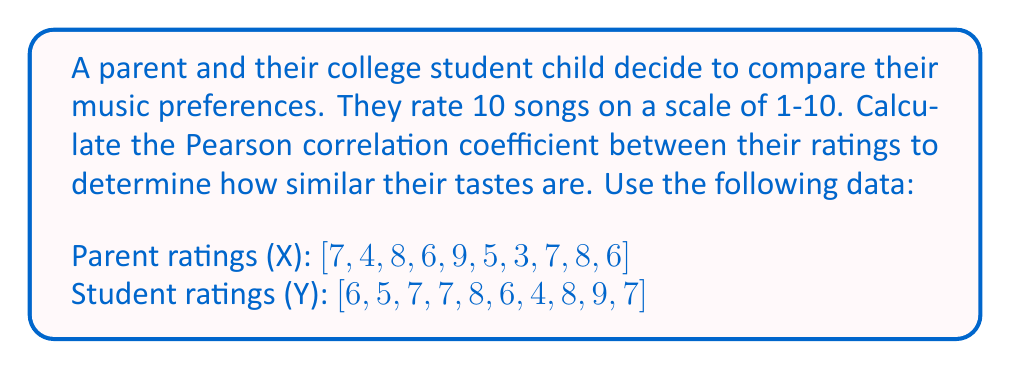Can you answer this question? To calculate the Pearson correlation coefficient, we'll use the formula:

$$ r = \frac{\sum_{i=1}^{n} (x_i - \bar{x})(y_i - \bar{y})}{\sqrt{\sum_{i=1}^{n} (x_i - \bar{x})^2 \sum_{i=1}^{n} (y_i - \bar{y})^2}} $$

Where $x_i$ and $y_i$ are individual values, $\bar{x}$ and $\bar{y}$ are means, and $n$ is the number of pairs.

Step 1: Calculate the means
$\bar{x} = \frac{7+4+8+6+9+5+3+7+8+6}{10} = 6.3$
$\bar{y} = \frac{6+5+7+7+8+6+4+8+9+7}{10} = 6.7$

Step 2: Calculate $(x_i - \bar{x})$, $(y_i - \bar{y})$, $(x_i - \bar{x})^2$, $(y_i - \bar{y})^2$, and $(x_i - \bar{x})(y_i - \bar{y})$ for each pair

Step 3: Sum the results
$\sum (x_i - \bar{x})(y_i - \bar{y}) = 16.9$
$\sum (x_i - \bar{x})^2 = 39.1$
$\sum (y_i - \bar{y})^2 = 17.1$

Step 4: Apply the formula
$$ r = \frac{16.9}{\sqrt{39.1 \times 17.1}} = \frac{16.9}{\sqrt{668.61}} = \frac{16.9}{25.86} \approx 0.6535 $$
Answer: The Pearson correlation coefficient between the parent and student music preferences is approximately 0.6535. 